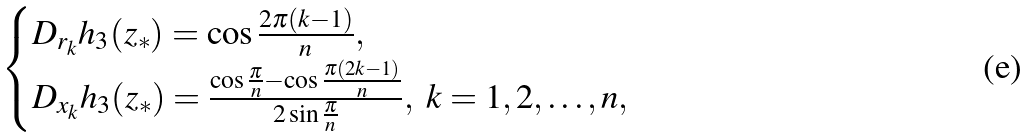<formula> <loc_0><loc_0><loc_500><loc_500>\begin{cases} D _ { r _ { k } } h _ { 3 } ( z _ { * } ) = \cos \frac { 2 \pi ( k - 1 ) } { n } , \\ D _ { x _ { k } } h _ { 3 } ( z _ { * } ) = \frac { \cos \frac { \pi } { n } - \cos \frac { \pi ( 2 k - 1 ) } { n } } { 2 \sin \frac { \pi } { n } } , \ k = 1 , 2 , \dots , n , \end{cases}</formula> 